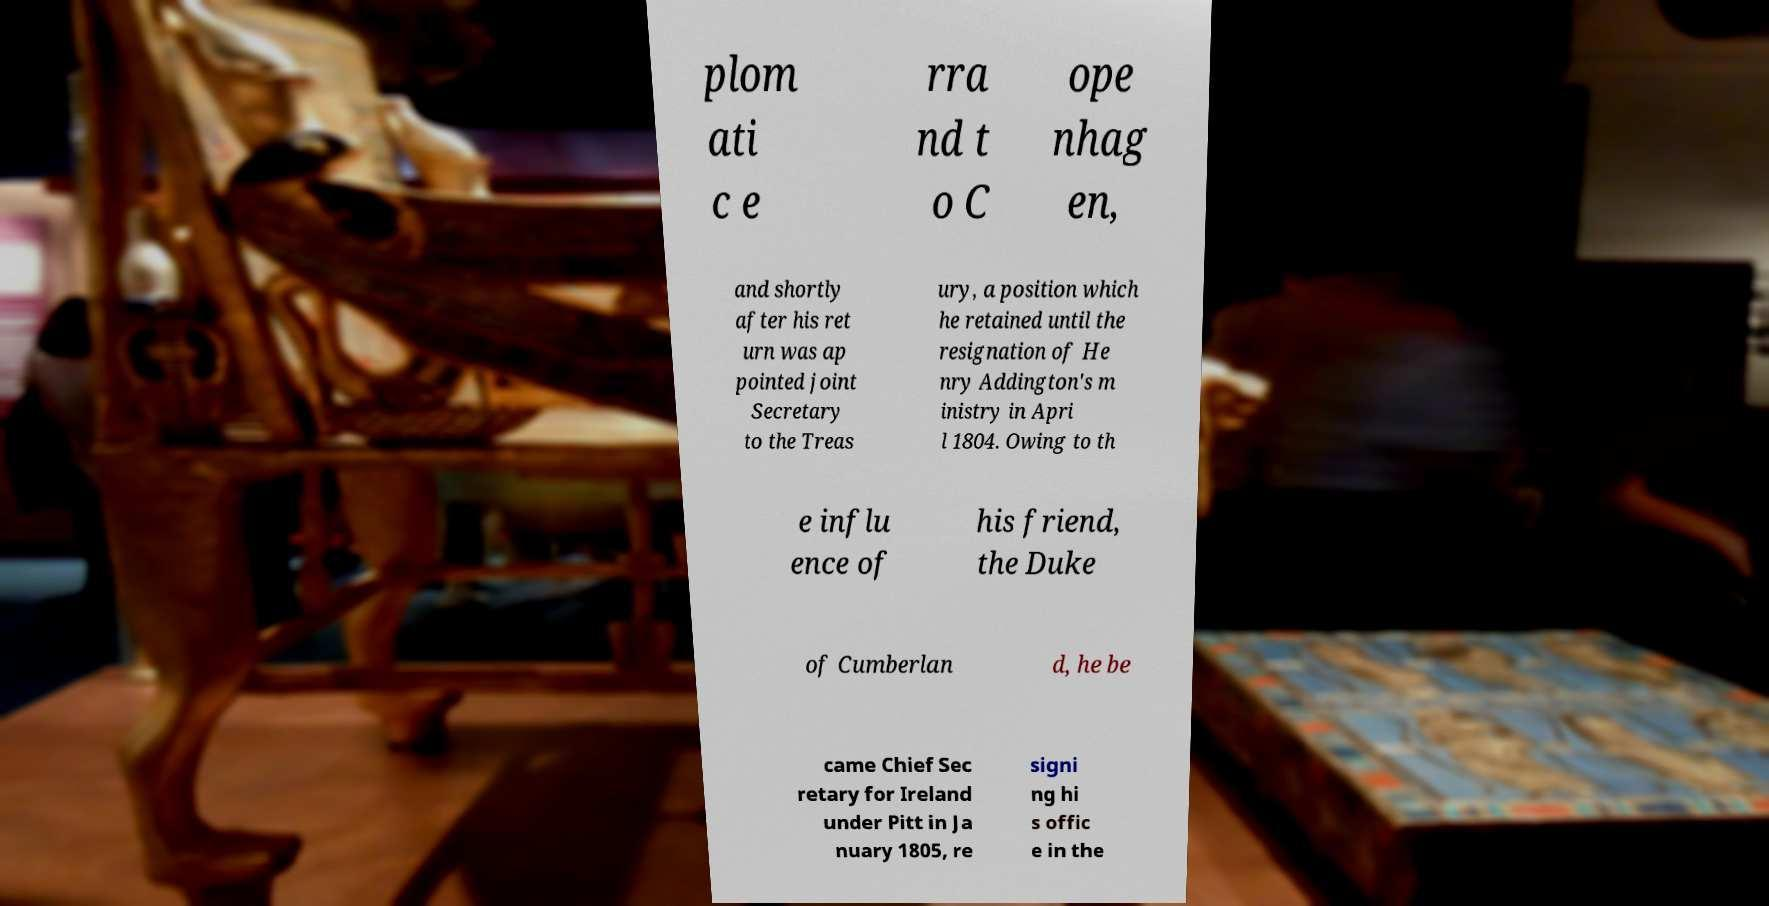What messages or text are displayed in this image? I need them in a readable, typed format. plom ati c e rra nd t o C ope nhag en, and shortly after his ret urn was ap pointed joint Secretary to the Treas ury, a position which he retained until the resignation of He nry Addington's m inistry in Apri l 1804. Owing to th e influ ence of his friend, the Duke of Cumberlan d, he be came Chief Sec retary for Ireland under Pitt in Ja nuary 1805, re signi ng hi s offic e in the 